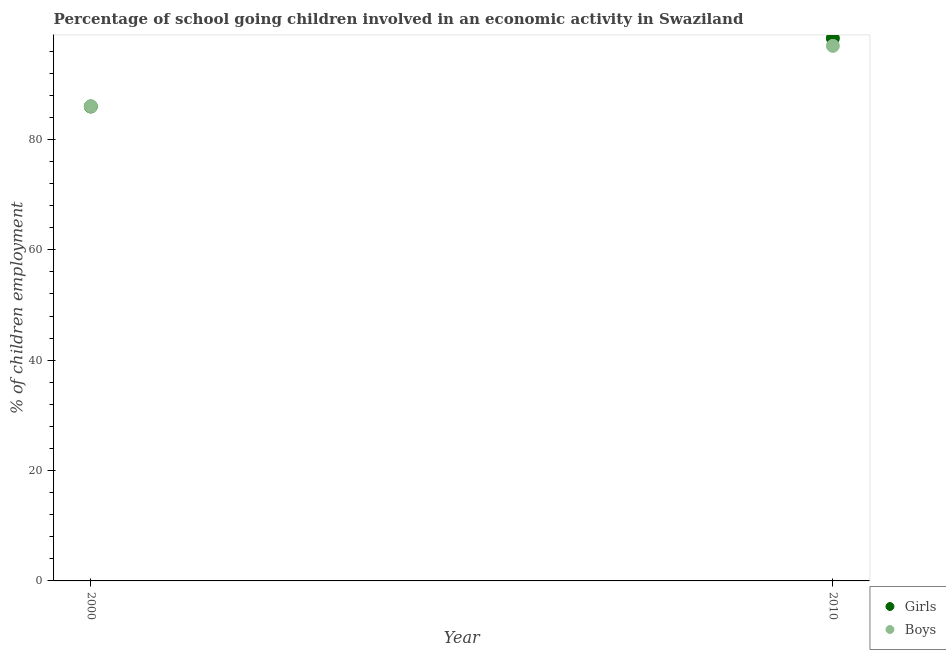What is the percentage of school going girls in 2000?
Make the answer very short. 85.96. Across all years, what is the maximum percentage of school going boys?
Provide a succinct answer. 96.95. Across all years, what is the minimum percentage of school going boys?
Give a very brief answer. 86. In which year was the percentage of school going boys maximum?
Your answer should be compact. 2010. In which year was the percentage of school going boys minimum?
Your answer should be compact. 2000. What is the total percentage of school going girls in the graph?
Provide a short and direct response. 184.28. What is the difference between the percentage of school going girls in 2000 and that in 2010?
Provide a succinct answer. -12.36. What is the difference between the percentage of school going boys in 2010 and the percentage of school going girls in 2000?
Your response must be concise. 10.99. What is the average percentage of school going boys per year?
Ensure brevity in your answer.  91.47. In the year 2010, what is the difference between the percentage of school going girls and percentage of school going boys?
Your answer should be very brief. 1.37. In how many years, is the percentage of school going boys greater than 72 %?
Your response must be concise. 2. What is the ratio of the percentage of school going girls in 2000 to that in 2010?
Your answer should be very brief. 0.87. Is the percentage of school going boys strictly less than the percentage of school going girls over the years?
Provide a succinct answer. No. How many dotlines are there?
Provide a succinct answer. 2. What is the difference between two consecutive major ticks on the Y-axis?
Your answer should be compact. 20. Does the graph contain any zero values?
Provide a succinct answer. No. Where does the legend appear in the graph?
Provide a succinct answer. Bottom right. How many legend labels are there?
Your response must be concise. 2. What is the title of the graph?
Give a very brief answer. Percentage of school going children involved in an economic activity in Swaziland. Does "Personal remittances" appear as one of the legend labels in the graph?
Give a very brief answer. No. What is the label or title of the Y-axis?
Keep it short and to the point. % of children employment. What is the % of children employment of Girls in 2000?
Provide a succinct answer. 85.96. What is the % of children employment in Boys in 2000?
Give a very brief answer. 86. What is the % of children employment in Girls in 2010?
Provide a short and direct response. 98.32. What is the % of children employment of Boys in 2010?
Provide a short and direct response. 96.95. Across all years, what is the maximum % of children employment in Girls?
Give a very brief answer. 98.32. Across all years, what is the maximum % of children employment of Boys?
Give a very brief answer. 96.95. Across all years, what is the minimum % of children employment in Girls?
Make the answer very short. 85.96. Across all years, what is the minimum % of children employment of Boys?
Ensure brevity in your answer.  86. What is the total % of children employment in Girls in the graph?
Keep it short and to the point. 184.28. What is the total % of children employment in Boys in the graph?
Your answer should be very brief. 182.95. What is the difference between the % of children employment in Girls in 2000 and that in 2010?
Keep it short and to the point. -12.36. What is the difference between the % of children employment in Boys in 2000 and that in 2010?
Make the answer very short. -10.95. What is the difference between the % of children employment of Girls in 2000 and the % of children employment of Boys in 2010?
Offer a very short reply. -10.99. What is the average % of children employment of Girls per year?
Your answer should be compact. 92.14. What is the average % of children employment of Boys per year?
Provide a short and direct response. 91.47. In the year 2000, what is the difference between the % of children employment of Girls and % of children employment of Boys?
Offer a very short reply. -0.04. In the year 2010, what is the difference between the % of children employment in Girls and % of children employment in Boys?
Give a very brief answer. 1.37. What is the ratio of the % of children employment in Girls in 2000 to that in 2010?
Ensure brevity in your answer.  0.87. What is the ratio of the % of children employment of Boys in 2000 to that in 2010?
Offer a very short reply. 0.89. What is the difference between the highest and the second highest % of children employment of Girls?
Offer a terse response. 12.36. What is the difference between the highest and the second highest % of children employment in Boys?
Your answer should be very brief. 10.95. What is the difference between the highest and the lowest % of children employment in Girls?
Offer a very short reply. 12.36. What is the difference between the highest and the lowest % of children employment in Boys?
Give a very brief answer. 10.95. 